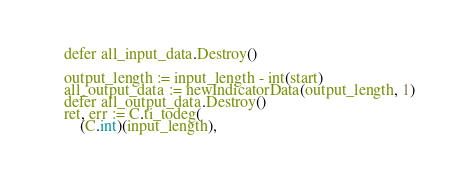Convert code to text. <code><loc_0><loc_0><loc_500><loc_500><_Go_>	defer all_input_data.Destroy()

	output_length := input_length - int(start)
	all_output_data := newIndicatorData(output_length, 1)
	defer all_output_data.Destroy()
	ret, err := C.ti_todeg(
		(C.int)(input_length),</code> 